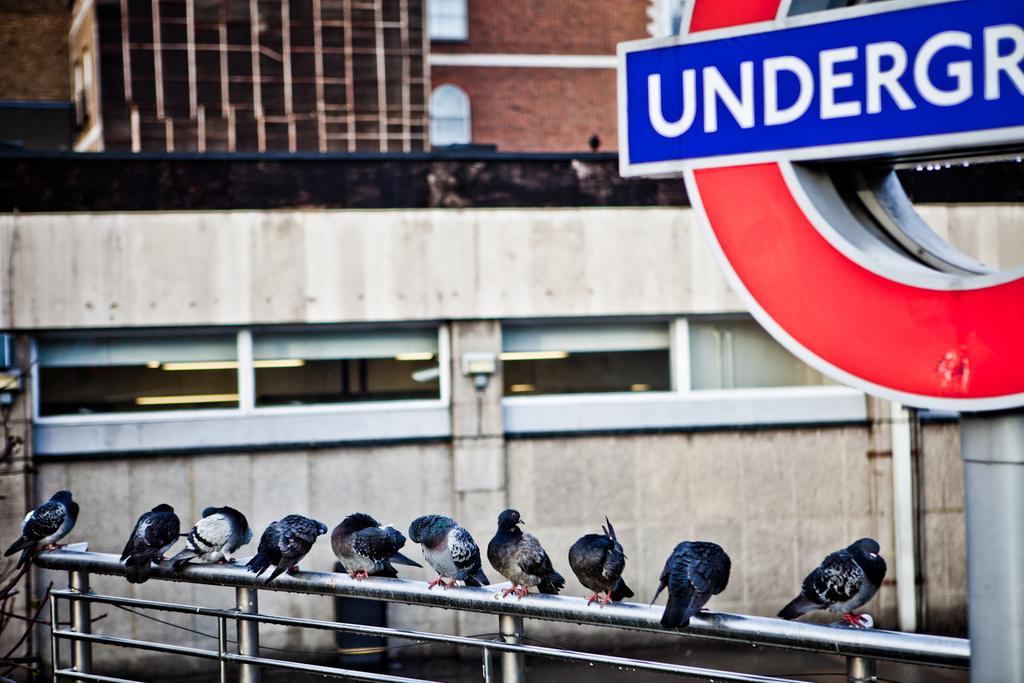What animals are present on the metal rod in the image? There are birds on a metal rod in the image. What can be seen on the right side of the image? There is a board with text on the right side of the image. What is visible in the background of the image? There is a building in the background of the image. What type of soda is being advertised on the board in the image? There is no soda or advertisement present on the board in the image; it only contains text. What type of belief system is represented by the birds on the metal rod? The image does not convey any belief system; it simply shows birds on a metal rod. 